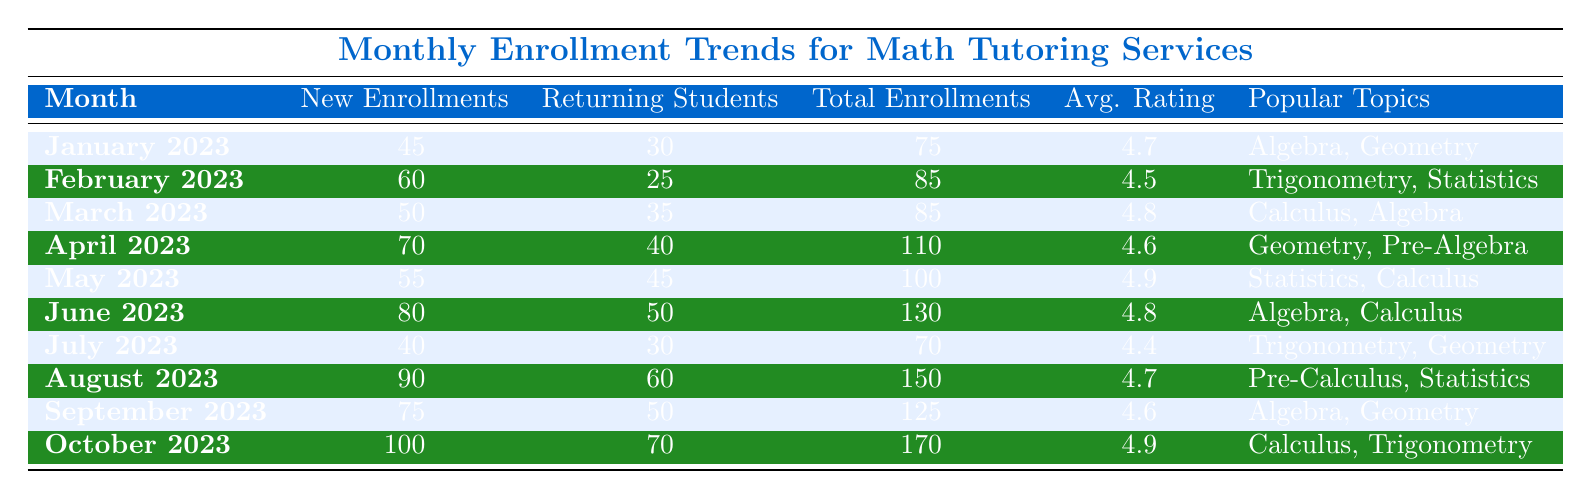What was the total number of enrollments in June 2023? The table shows that in June 2023, the Total Enrollments column lists 130.
Answer: 130 How many new enrollments were there in April 2023? Looking at the New Enrollments column for April 2023, the value is 70.
Answer: 70 Which month had the highest average session rating? By comparing the Average Session Rating of all months, October 2023 has the highest rating of 4.9.
Answer: October 2023 What is the difference in total enrollments between August 2023 and July 2023? August 2023 has 150 total enrollments, and July 2023 has 70. The difference is 150 - 70 = 80.
Answer: 80 How many returning students were there in March 2023, and what were the popular topics? In March 2023, there were 35 Returning Students, and the popular topics were Calculus and Algebra.
Answer: 35, Calculus and Algebra In which month did the least number of new enrollments occur? By reviewing the New Enrollments column, July 2023 shows the least with 40 new enrollments.
Answer: July 2023 Was the average session rating in May 2023 higher than that in February 2023? In May 2023, the average session rating is 4.9, while in February 2023 it is 4.5. Thus, May's rating is higher.
Answer: Yes What were the popular topics for the month with the highest number of total enrollments? October 2023 had the highest total enrollments of 170, with the popular topics being Calculus and Trigonometry.
Answer: Calculus and Trigonometry If the total enrollments from January to June are summed, what would the result be? The total enrollments from January (75), February (85), March (85), April (110), May (100), and June (130) sum up as follows: 75 + 85 + 85 + 110 + 100 + 130 = 585.
Answer: 585 Which month experienced a decline in returning students compared to the previous month? By checking the Returning Students column, August 2023 had 60, a drop from July 2023's 30, which is an increase. However, May 2023 had 45 returning students, followed by 50 in June. Therefore, there was no decline in this case.
Answer: There is no decline 